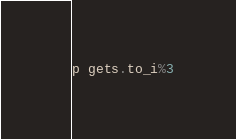<code> <loc_0><loc_0><loc_500><loc_500><_Ruby_>p gets.to_i%3</code> 